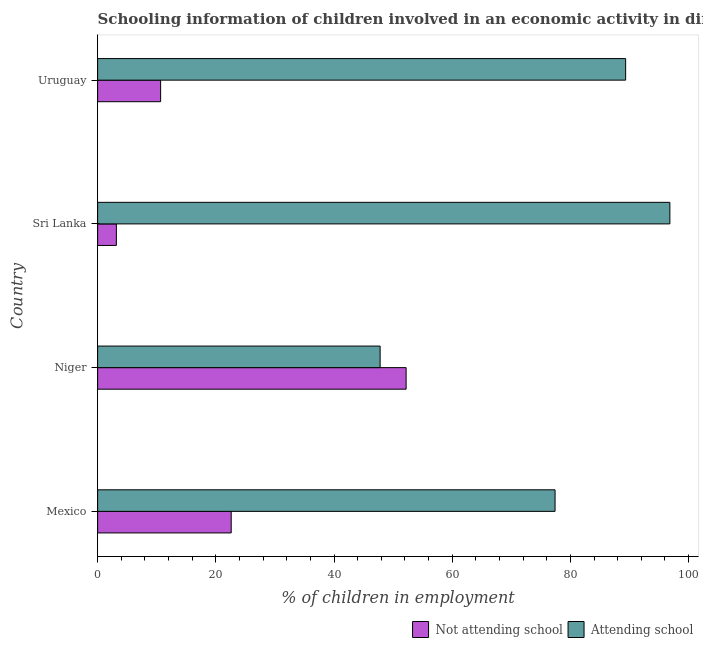Are the number of bars per tick equal to the number of legend labels?
Offer a terse response. Yes. Are the number of bars on each tick of the Y-axis equal?
Give a very brief answer. Yes. How many bars are there on the 1st tick from the top?
Keep it short and to the point. 2. How many bars are there on the 3rd tick from the bottom?
Offer a terse response. 2. What is the label of the 4th group of bars from the top?
Your response must be concise. Mexico. What is the percentage of employed children who are attending school in Sri Lanka?
Ensure brevity in your answer.  96.83. Across all countries, what is the maximum percentage of employed children who are not attending school?
Provide a succinct answer. 52.2. Across all countries, what is the minimum percentage of employed children who are not attending school?
Offer a terse response. 3.17. In which country was the percentage of employed children who are not attending school maximum?
Provide a short and direct response. Niger. In which country was the percentage of employed children who are not attending school minimum?
Give a very brief answer. Sri Lanka. What is the total percentage of employed children who are attending school in the graph?
Make the answer very short. 311.37. What is the difference between the percentage of employed children who are not attending school in Niger and that in Uruguay?
Provide a short and direct response. 41.54. What is the difference between the percentage of employed children who are attending school in Sri Lanka and the percentage of employed children who are not attending school in Mexico?
Your answer should be very brief. 74.23. What is the average percentage of employed children who are attending school per country?
Ensure brevity in your answer.  77.84. What is the difference between the percentage of employed children who are not attending school and percentage of employed children who are attending school in Uruguay?
Give a very brief answer. -78.68. What is the ratio of the percentage of employed children who are attending school in Mexico to that in Uruguay?
Give a very brief answer. 0.87. Is the percentage of employed children who are attending school in Niger less than that in Uruguay?
Ensure brevity in your answer.  Yes. What is the difference between the highest and the second highest percentage of employed children who are not attending school?
Provide a short and direct response. 29.6. What is the difference between the highest and the lowest percentage of employed children who are not attending school?
Give a very brief answer. 49.03. In how many countries, is the percentage of employed children who are not attending school greater than the average percentage of employed children who are not attending school taken over all countries?
Offer a very short reply. 2. What does the 1st bar from the top in Uruguay represents?
Keep it short and to the point. Attending school. What does the 1st bar from the bottom in Uruguay represents?
Make the answer very short. Not attending school. How many bars are there?
Provide a short and direct response. 8. Are all the bars in the graph horizontal?
Give a very brief answer. Yes. Are the values on the major ticks of X-axis written in scientific E-notation?
Provide a short and direct response. No. How many legend labels are there?
Keep it short and to the point. 2. How are the legend labels stacked?
Your answer should be very brief. Horizontal. What is the title of the graph?
Your answer should be compact. Schooling information of children involved in an economic activity in different countries. What is the label or title of the X-axis?
Your response must be concise. % of children in employment. What is the % of children in employment of Not attending school in Mexico?
Make the answer very short. 22.6. What is the % of children in employment in Attending school in Mexico?
Your answer should be very brief. 77.4. What is the % of children in employment in Not attending school in Niger?
Your answer should be very brief. 52.2. What is the % of children in employment of Attending school in Niger?
Give a very brief answer. 47.8. What is the % of children in employment in Not attending school in Sri Lanka?
Your answer should be very brief. 3.17. What is the % of children in employment of Attending school in Sri Lanka?
Keep it short and to the point. 96.83. What is the % of children in employment in Not attending school in Uruguay?
Provide a short and direct response. 10.66. What is the % of children in employment of Attending school in Uruguay?
Provide a succinct answer. 89.34. Across all countries, what is the maximum % of children in employment in Not attending school?
Offer a very short reply. 52.2. Across all countries, what is the maximum % of children in employment in Attending school?
Your answer should be compact. 96.83. Across all countries, what is the minimum % of children in employment of Not attending school?
Offer a very short reply. 3.17. Across all countries, what is the minimum % of children in employment of Attending school?
Your response must be concise. 47.8. What is the total % of children in employment of Not attending school in the graph?
Make the answer very short. 88.63. What is the total % of children in employment of Attending school in the graph?
Your answer should be very brief. 311.37. What is the difference between the % of children in employment in Not attending school in Mexico and that in Niger?
Your response must be concise. -29.6. What is the difference between the % of children in employment of Attending school in Mexico and that in Niger?
Your answer should be compact. 29.6. What is the difference between the % of children in employment of Not attending school in Mexico and that in Sri Lanka?
Your answer should be compact. 19.43. What is the difference between the % of children in employment in Attending school in Mexico and that in Sri Lanka?
Offer a very short reply. -19.43. What is the difference between the % of children in employment in Not attending school in Mexico and that in Uruguay?
Keep it short and to the point. 11.94. What is the difference between the % of children in employment in Attending school in Mexico and that in Uruguay?
Keep it short and to the point. -11.94. What is the difference between the % of children in employment of Not attending school in Niger and that in Sri Lanka?
Offer a very short reply. 49.03. What is the difference between the % of children in employment in Attending school in Niger and that in Sri Lanka?
Your answer should be compact. -49.03. What is the difference between the % of children in employment in Not attending school in Niger and that in Uruguay?
Your answer should be compact. 41.54. What is the difference between the % of children in employment of Attending school in Niger and that in Uruguay?
Give a very brief answer. -41.54. What is the difference between the % of children in employment in Not attending school in Sri Lanka and that in Uruguay?
Make the answer very short. -7.49. What is the difference between the % of children in employment of Attending school in Sri Lanka and that in Uruguay?
Give a very brief answer. 7.49. What is the difference between the % of children in employment in Not attending school in Mexico and the % of children in employment in Attending school in Niger?
Your answer should be very brief. -25.2. What is the difference between the % of children in employment in Not attending school in Mexico and the % of children in employment in Attending school in Sri Lanka?
Offer a terse response. -74.23. What is the difference between the % of children in employment in Not attending school in Mexico and the % of children in employment in Attending school in Uruguay?
Ensure brevity in your answer.  -66.74. What is the difference between the % of children in employment in Not attending school in Niger and the % of children in employment in Attending school in Sri Lanka?
Ensure brevity in your answer.  -44.63. What is the difference between the % of children in employment in Not attending school in Niger and the % of children in employment in Attending school in Uruguay?
Keep it short and to the point. -37.14. What is the difference between the % of children in employment of Not attending school in Sri Lanka and the % of children in employment of Attending school in Uruguay?
Your response must be concise. -86.17. What is the average % of children in employment in Not attending school per country?
Offer a very short reply. 22.16. What is the average % of children in employment of Attending school per country?
Ensure brevity in your answer.  77.84. What is the difference between the % of children in employment in Not attending school and % of children in employment in Attending school in Mexico?
Keep it short and to the point. -54.8. What is the difference between the % of children in employment of Not attending school and % of children in employment of Attending school in Sri Lanka?
Ensure brevity in your answer.  -93.66. What is the difference between the % of children in employment in Not attending school and % of children in employment in Attending school in Uruguay?
Offer a very short reply. -78.68. What is the ratio of the % of children in employment in Not attending school in Mexico to that in Niger?
Your answer should be compact. 0.43. What is the ratio of the % of children in employment of Attending school in Mexico to that in Niger?
Your answer should be compact. 1.62. What is the ratio of the % of children in employment in Not attending school in Mexico to that in Sri Lanka?
Give a very brief answer. 7.13. What is the ratio of the % of children in employment of Attending school in Mexico to that in Sri Lanka?
Provide a short and direct response. 0.8. What is the ratio of the % of children in employment of Not attending school in Mexico to that in Uruguay?
Offer a terse response. 2.12. What is the ratio of the % of children in employment in Attending school in Mexico to that in Uruguay?
Give a very brief answer. 0.87. What is the ratio of the % of children in employment of Not attending school in Niger to that in Sri Lanka?
Offer a very short reply. 16.46. What is the ratio of the % of children in employment of Attending school in Niger to that in Sri Lanka?
Give a very brief answer. 0.49. What is the ratio of the % of children in employment of Not attending school in Niger to that in Uruguay?
Offer a very short reply. 4.9. What is the ratio of the % of children in employment in Attending school in Niger to that in Uruguay?
Your answer should be compact. 0.54. What is the ratio of the % of children in employment in Not attending school in Sri Lanka to that in Uruguay?
Your answer should be very brief. 0.3. What is the ratio of the % of children in employment in Attending school in Sri Lanka to that in Uruguay?
Your response must be concise. 1.08. What is the difference between the highest and the second highest % of children in employment in Not attending school?
Your response must be concise. 29.6. What is the difference between the highest and the second highest % of children in employment in Attending school?
Your answer should be very brief. 7.49. What is the difference between the highest and the lowest % of children in employment in Not attending school?
Provide a succinct answer. 49.03. What is the difference between the highest and the lowest % of children in employment in Attending school?
Provide a short and direct response. 49.03. 